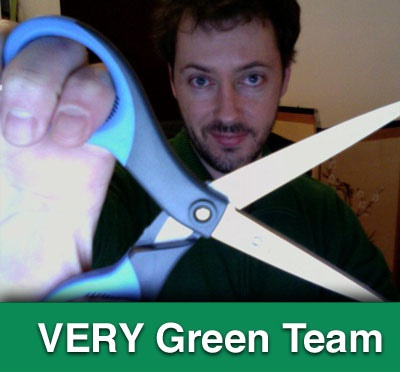Describe the objects in this image and their specific colors. I can see people in black, lightgray, gray, and darkgray tones and scissors in black, lightgray, lightblue, and gray tones in this image. 